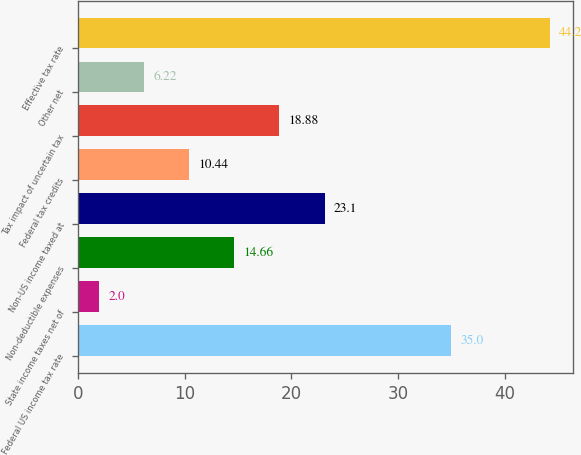<chart> <loc_0><loc_0><loc_500><loc_500><bar_chart><fcel>Federal US income tax rate<fcel>State income taxes net of<fcel>Non-deductible expenses<fcel>Non-US income taxed at<fcel>Federal tax credits<fcel>Tax impact of uncertain tax<fcel>Other net<fcel>Effective tax rate<nl><fcel>35<fcel>2<fcel>14.66<fcel>23.1<fcel>10.44<fcel>18.88<fcel>6.22<fcel>44.2<nl></chart> 